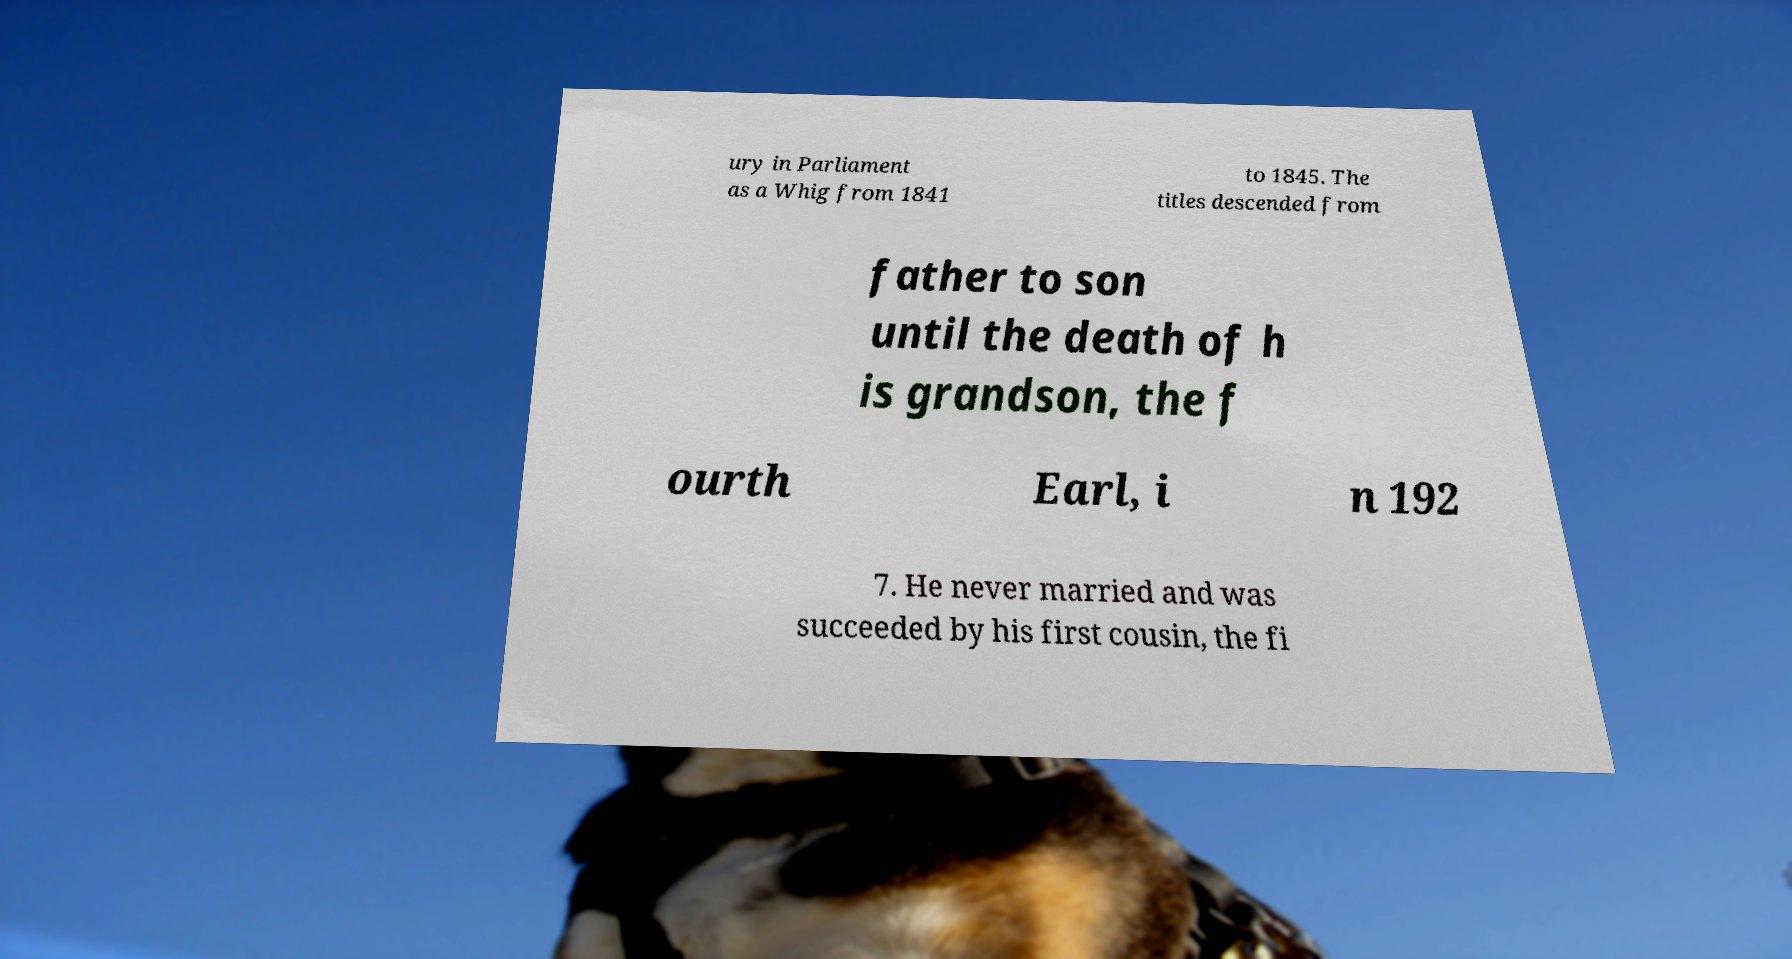Please read and relay the text visible in this image. What does it say? ury in Parliament as a Whig from 1841 to 1845. The titles descended from father to son until the death of h is grandson, the f ourth Earl, i n 192 7. He never married and was succeeded by his first cousin, the fi 